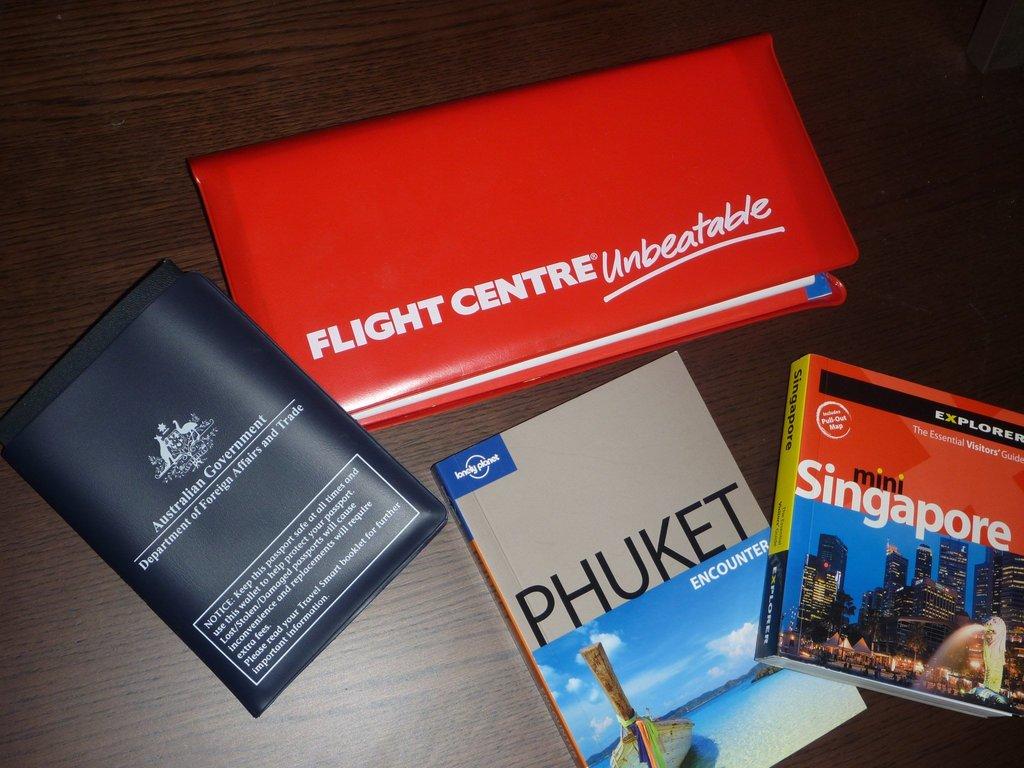Where is the department of foreign affairs and trade?
Your answer should be compact. Australia. What is unbeatable?
Provide a short and direct response. Flight centre. 